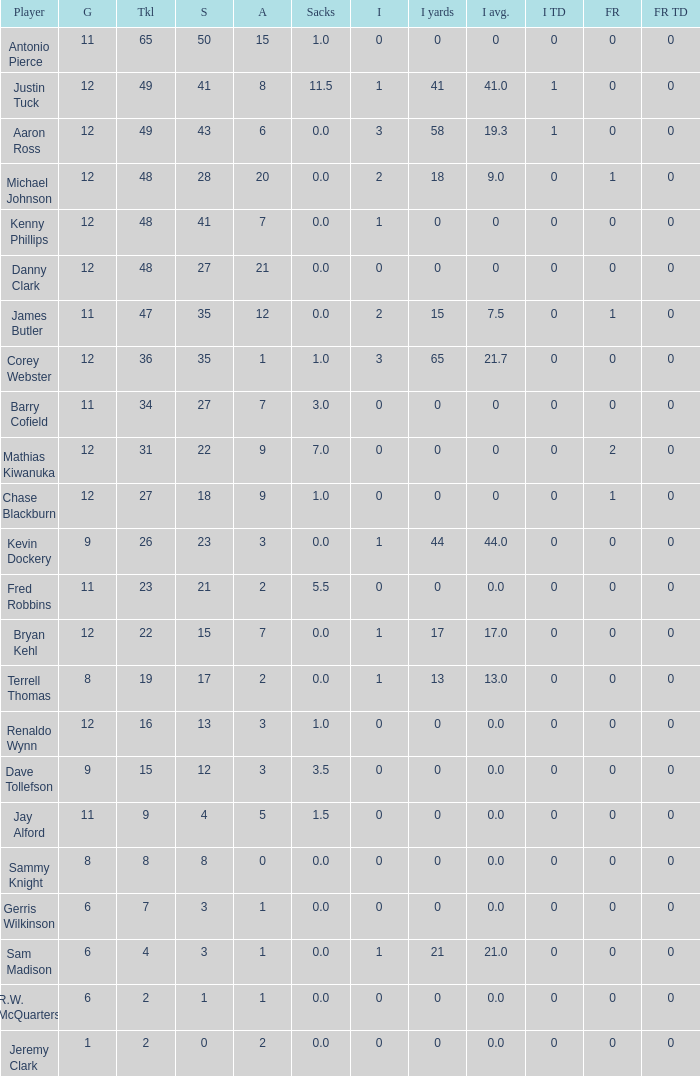Name the least int yards when sacks is 11.5 41.0. 